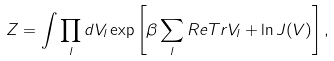<formula> <loc_0><loc_0><loc_500><loc_500>Z = \int \prod _ { l } d V _ { l } \exp \left [ \beta \sum _ { l } { R e T r } V _ { l } + \ln J ( V ) \right ] ,</formula> 